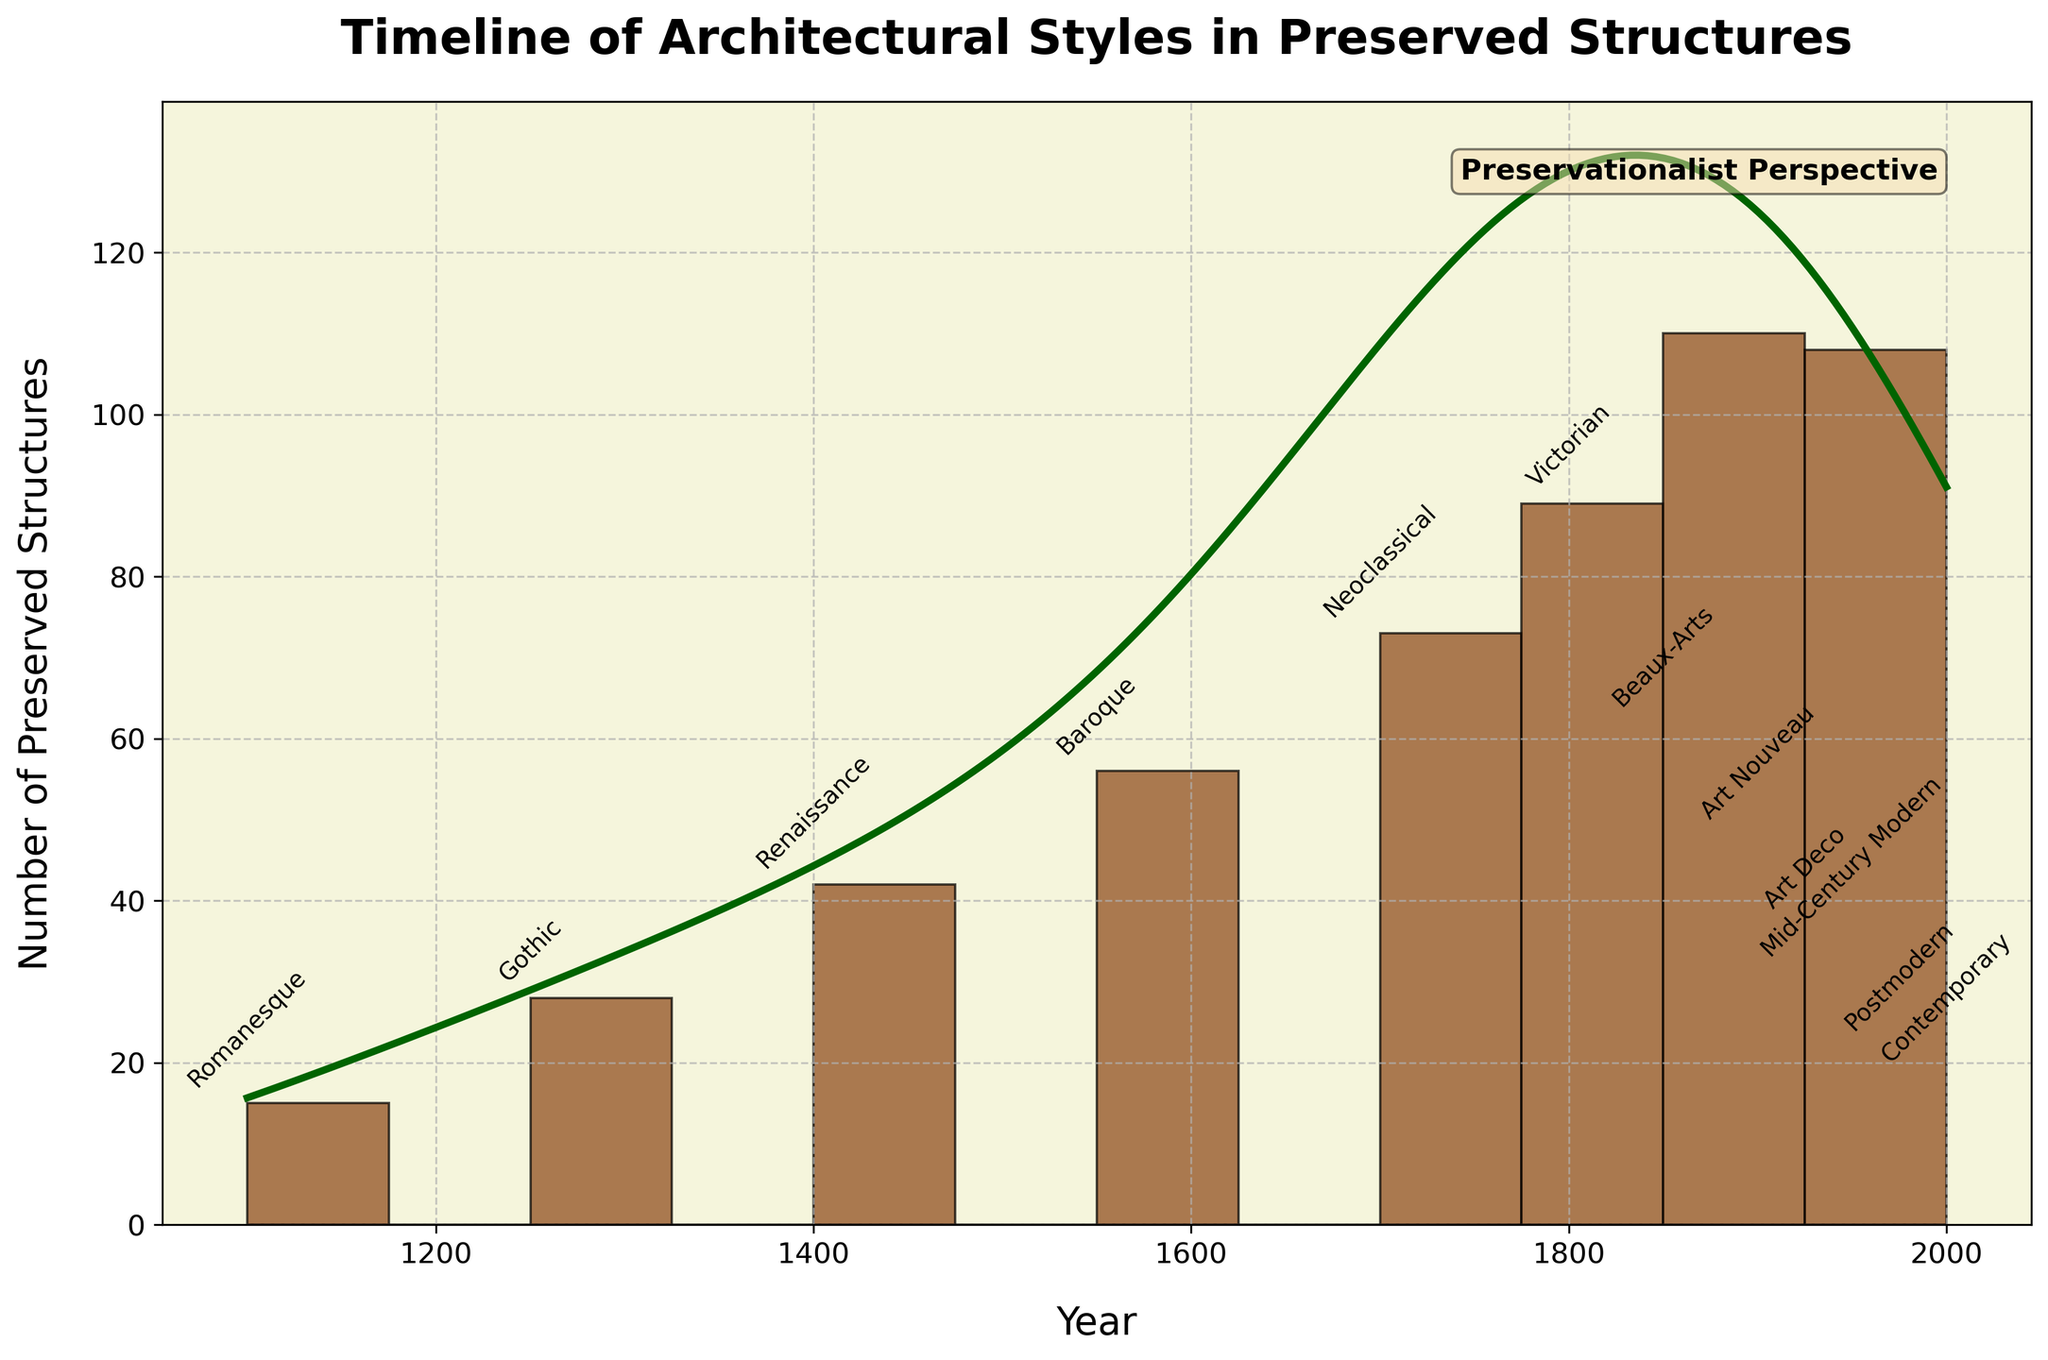what is the title of the figure? The title is located at the top of the figure and is written in a bold and larger font compared to other elements. The title summarizes the main topic of the plot.
Answer: Timeline of Architectural Styles in Preserved Structures what are the labels on the x-axis and y-axis? The x-axis and y-axis labels are located below and to the left of the respective axes. These labels describe what each axis represents.
Answer: Year, Number of Preserved Structures Which architectural style corresponds to the highest number of preserved structures? To identify the style with the highest number of preserved structures, look for the bar with the highest peak on the histogram and read its label. The count is also indicated numerically.
Answer: Victorian During which period did the number of preserved structures start to decline? Observe the histogram and KDE curve to find the highest peak, then check subsequent periods for a decrease in values. The decline begins after the highest bar.
Answer: After the Victorian period (1800) What is the range of years displayed in the histogram? Inspect the x-axis to find the minimum and maximum year values displayed on the histogram. This range covers the entire timeline shown in the figure.
Answer: 1100 to 2000 How is the density curve scaled in relation to the histogram bars? The density curve (KDE) is scaled to match the height of the histogram bars. Look at the KDE's peak and compare it to the tallest bar. The KDE is adjusted to align with the highest bar for accurate visual comparison.
Answer: Scaled to match the histogram height Which architectural style is from the earliest period according to the figure? Identify the earliest year on the x-axis and read the architectural style label corresponding to that year. The label will be annotated near the bar representing this period.
Answer: Romanesque How many architectural styles have more than 50 preserved structures? Count the bars in the histogram where the number of preserved structures exceed 50, based on the numerical annotations and bar heights.
Answer: Three styles (Baroque, Neoclassical, Victorian) Compare the number of preserved structures between Gothic and Art Deco styles. Locate the histogram bars corresponding to Gothic and Art Deco styles, and note their heights or numerical values. Compare these values to determine the difference or relative numbers.
Answer: Gothic (28) vs. Art Deco (37) What's the trend in the number of preserved structures from the Renaissance to the Beaux-Arts period? Examine the histogram bars and KDE curve between the Renaissance and Beaux-Arts periods. Identify any increases or decreases in the number of preserved structures over these timeframes.
Answer: Increasing trend from Renaissance to Victorian, then a decrease to Beaux-Arts 